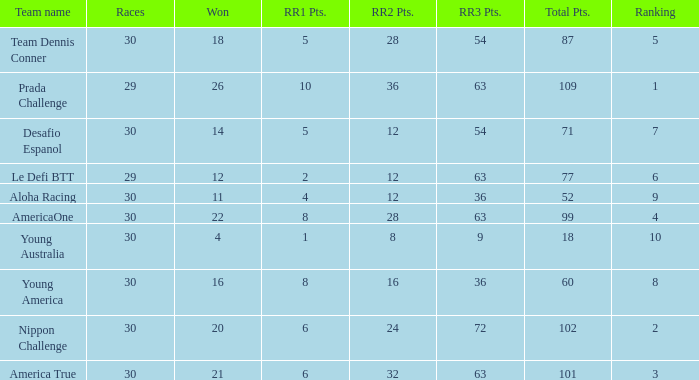Name the ranking for rr2 pts being 8 10.0. 